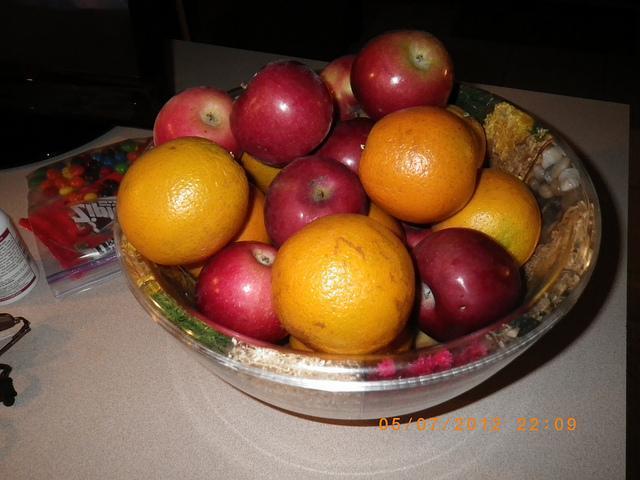How many kinds of fruit are in the image?
Give a very brief answer. 2. How many apples are in the photo?
Give a very brief answer. 7. How many oranges can you see?
Give a very brief answer. 3. 